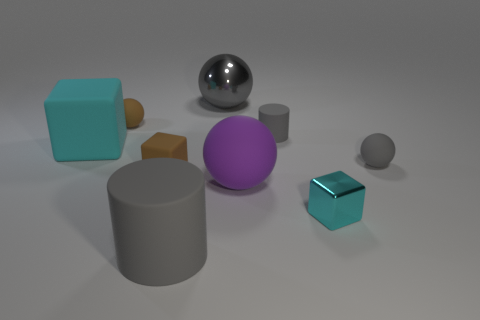Subtract all tiny cubes. How many cubes are left? 1 Subtract all brown blocks. How many blocks are left? 2 Add 1 tiny green rubber cylinders. How many objects exist? 10 Subtract all cubes. How many objects are left? 6 Subtract 4 balls. How many balls are left? 0 Subtract all purple cubes. How many gray spheres are left? 2 Subtract all cyan objects. Subtract all green things. How many objects are left? 7 Add 8 purple things. How many purple things are left? 9 Add 7 purple things. How many purple things exist? 8 Subtract 0 blue cubes. How many objects are left? 9 